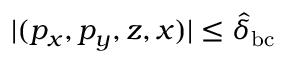Convert formula to latex. <formula><loc_0><loc_0><loc_500><loc_500>| ( p _ { x } , p _ { y } , z , x ) | \leq \hat { \delta } _ { b c }</formula> 